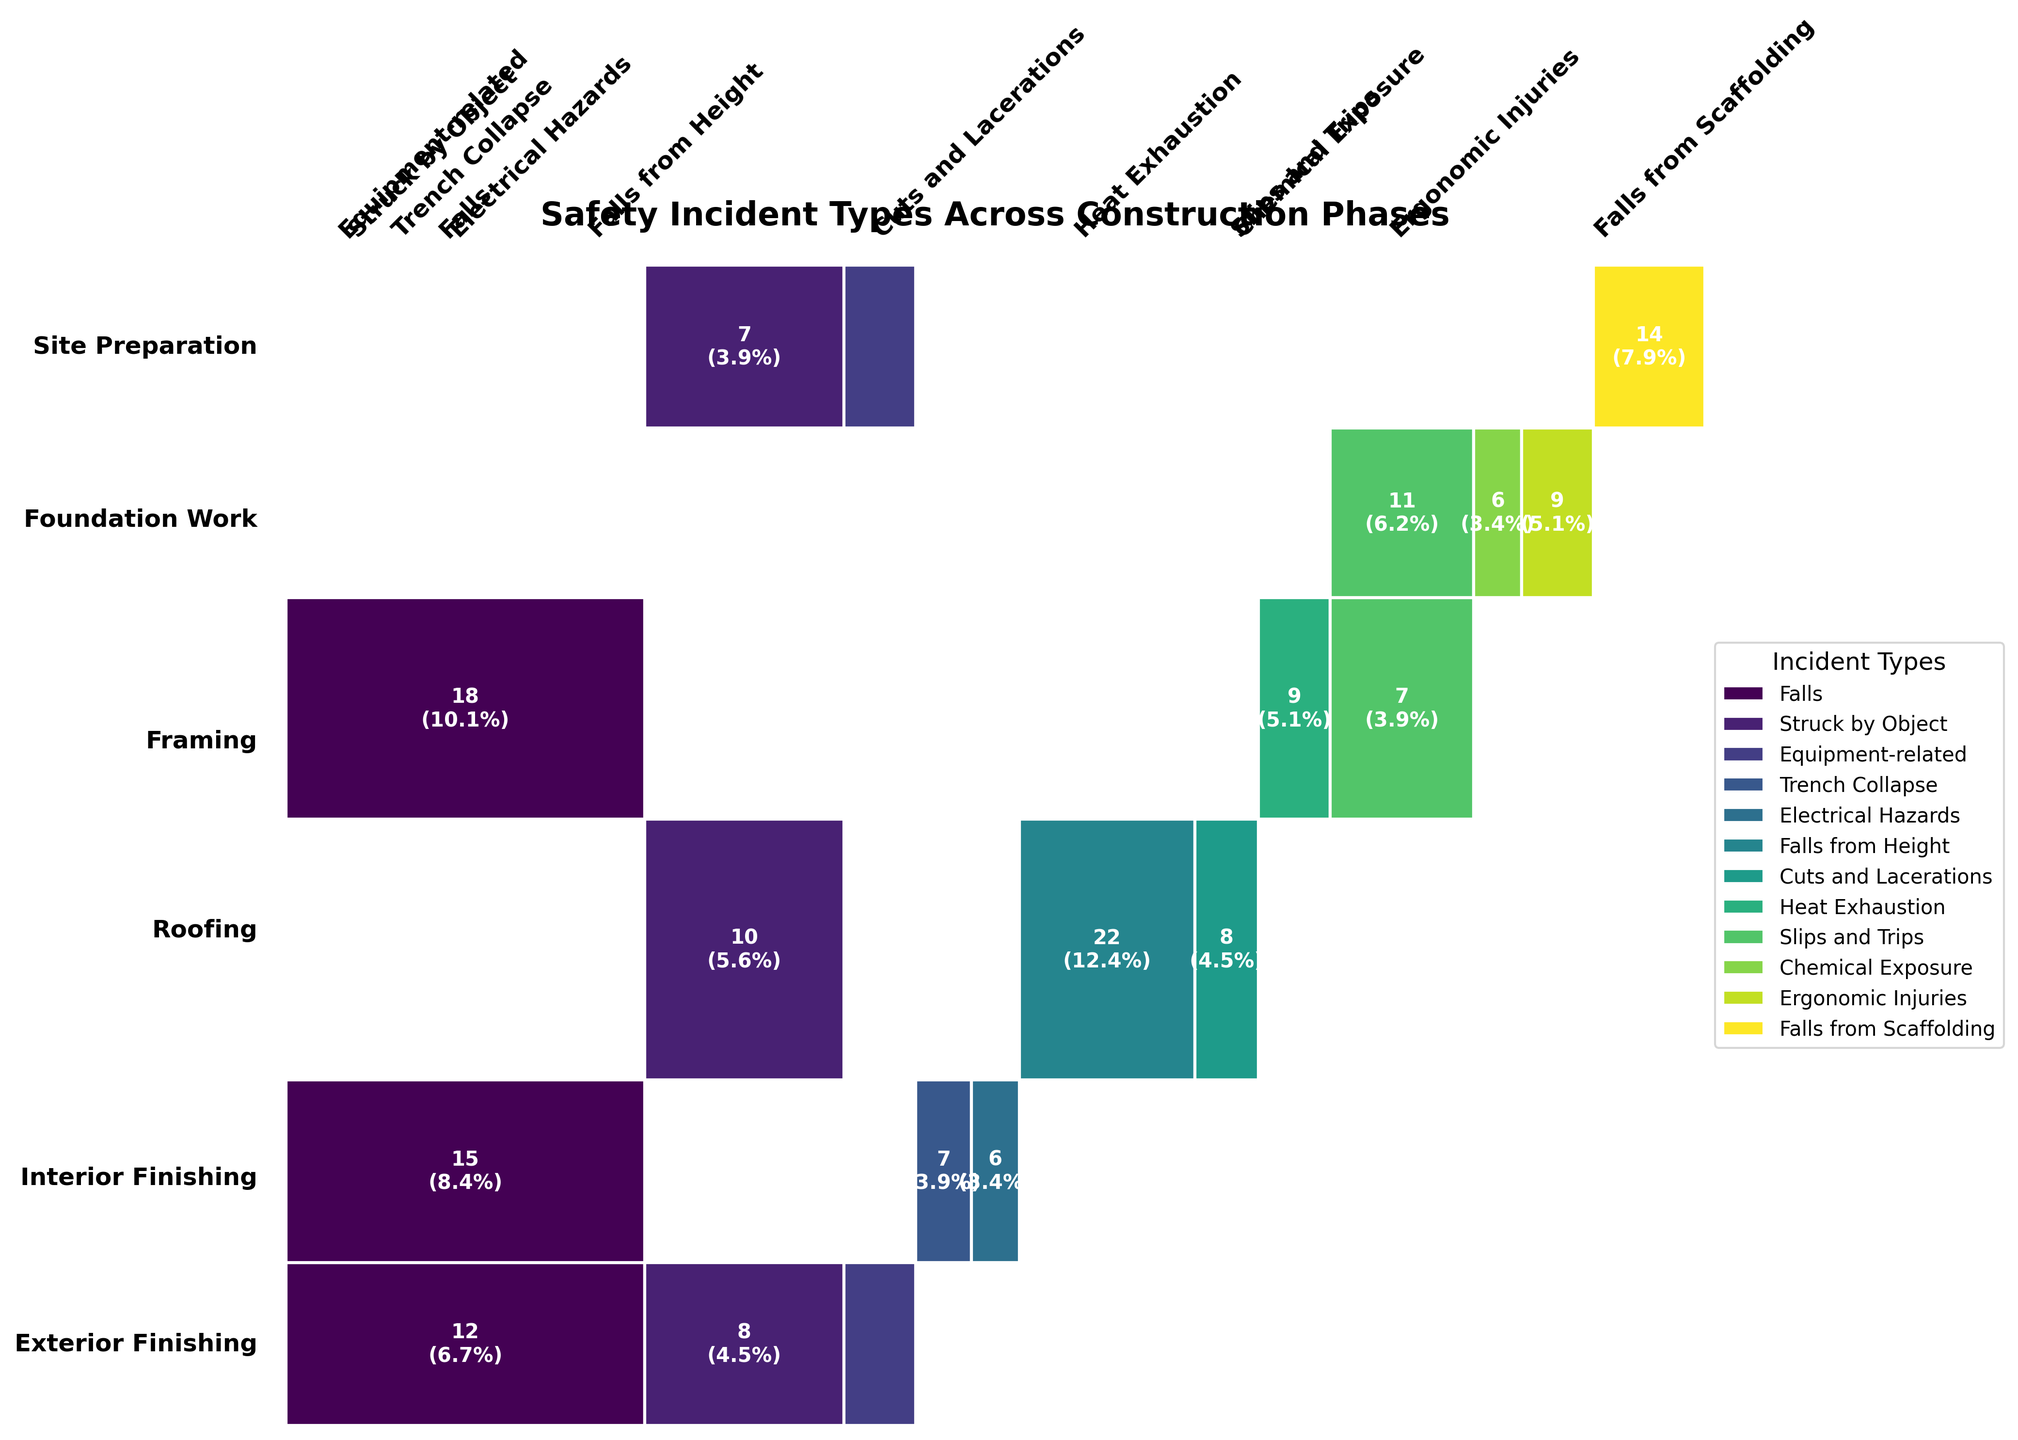How many different types of safety incidents are displayed in the plot? Count the unique labels in the 'Incident Types' axis at the top of the plot.
Answer: 14 Which construction phase has the highest frequency of 'Falls' incidents? Identify the construction phases (from the leftmost axis), and look for the highest proportion of the color associated with 'Falls'.
Answer: Framing What is the total frequency of 'Falls' incidents across all construction phases? Sum up the frequencies of 'Falls' incidents shown in each segment labeled 'Falls'.
Answer: 67 Does the 'Roofing' phase have more 'Falls' or 'Heat Exhaustion' incidents? Compare the heights of the segments under 'Roofing' for 'Falls' and 'Heat Exhaustion' based on the respective colors.
Answer: Falls Which incident type appears the most frequently in the 'Interior Finishing' phase? Look at the 'Interior Finishing' phase and identify the tallest segment by color.
Answer: Slips and Trips Which incident type has the least occurrences in the 'Exterior Finishing' phase? Look at the 'Exterior Finishing' phase and identify the shortest segment by color.
Answer: Equipment-related What is the combined frequency of 'Struck by Object' incidents in 'Site Preparation' and 'Framing' phases? Sum the frequencies of 'Struck by Object' in 'Site Preparation' and 'Framing'.
Answer: 18 Which incident type represents a higher proportion of incidents during 'Foundation Work' than in 'Site Preparation'? Compare incident types by checking proportions in 'Foundation Work' versus 'Site Preparation'.
Answer: Trench Collapse Are there more 'Equipment-related' incidents during 'Exterior Finishing' or 'Site Preparation'? Compare the heights of segments corresponding to 'Equipment-related' in 'Exterior Finishing' and 'Site Preparation'.
Answer: Site Preparation What proportion of safety incidents are 'Falls from Height' in the 'Framing' phase? Identify the segment for 'Falls from Height' under 'Framing' and calculate its proportion relative to the total.
Answer: 0.073 (or 7.3%) 